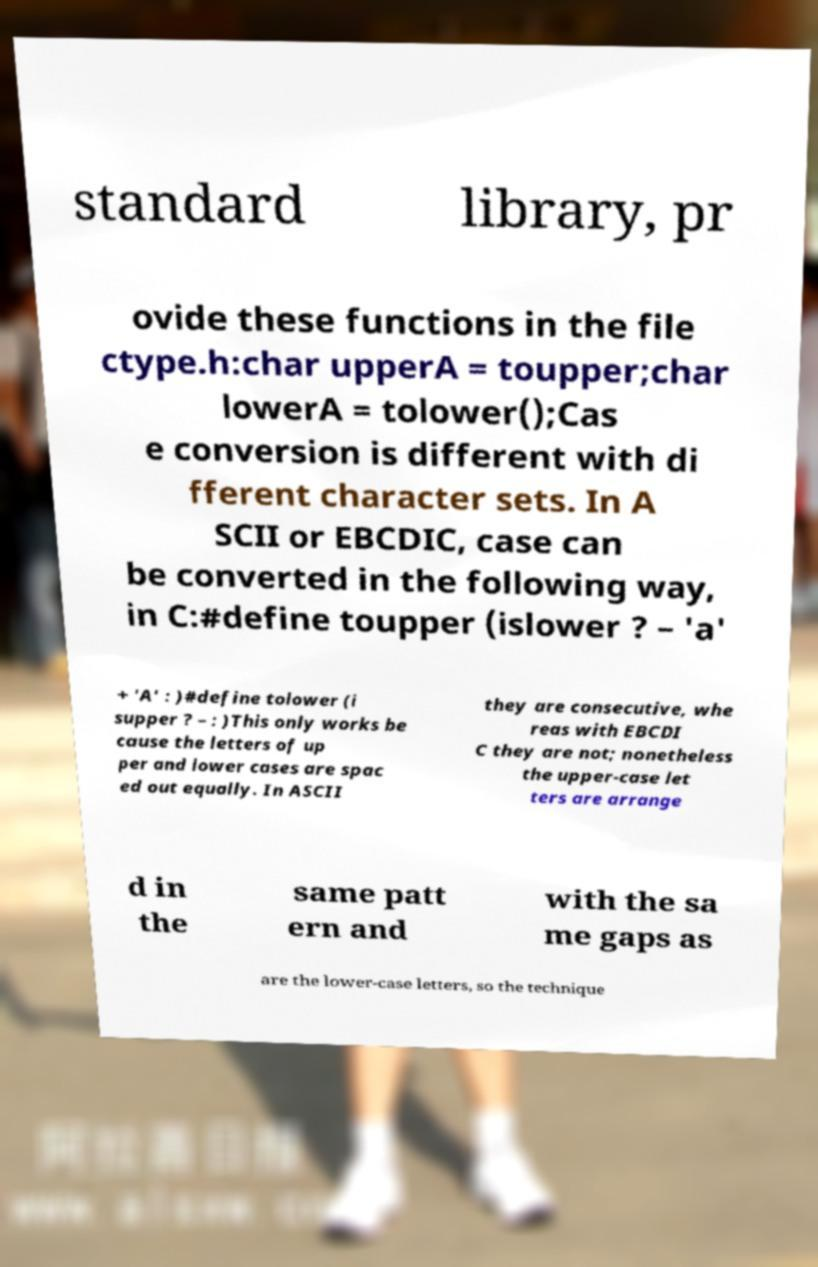Could you assist in decoding the text presented in this image and type it out clearly? standard library, pr ovide these functions in the file ctype.h:char upperA = toupper;char lowerA = tolower();Cas e conversion is different with di fferent character sets. In A SCII or EBCDIC, case can be converted in the following way, in C:#define toupper (islower ? – 'a' + 'A' : )#define tolower (i supper ? – : )This only works be cause the letters of up per and lower cases are spac ed out equally. In ASCII they are consecutive, whe reas with EBCDI C they are not; nonetheless the upper-case let ters are arrange d in the same patt ern and with the sa me gaps as are the lower-case letters, so the technique 